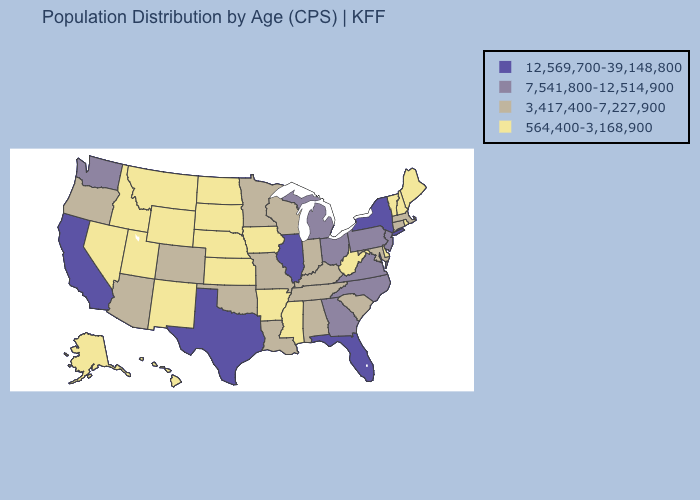What is the value of Colorado?
Concise answer only. 3,417,400-7,227,900. Among the states that border Massachusetts , does Rhode Island have the lowest value?
Answer briefly. Yes. Name the states that have a value in the range 3,417,400-7,227,900?
Short answer required. Alabama, Arizona, Colorado, Connecticut, Indiana, Kentucky, Louisiana, Maryland, Massachusetts, Minnesota, Missouri, Oklahoma, Oregon, South Carolina, Tennessee, Wisconsin. Does Arkansas have the same value as Utah?
Answer briefly. Yes. What is the highest value in states that border Massachusetts?
Give a very brief answer. 12,569,700-39,148,800. Among the states that border Rhode Island , which have the lowest value?
Give a very brief answer. Connecticut, Massachusetts. Name the states that have a value in the range 564,400-3,168,900?
Answer briefly. Alaska, Arkansas, Delaware, Hawaii, Idaho, Iowa, Kansas, Maine, Mississippi, Montana, Nebraska, Nevada, New Hampshire, New Mexico, North Dakota, Rhode Island, South Dakota, Utah, Vermont, West Virginia, Wyoming. Is the legend a continuous bar?
Keep it brief. No. What is the lowest value in states that border Kansas?
Be succinct. 564,400-3,168,900. Name the states that have a value in the range 564,400-3,168,900?
Be succinct. Alaska, Arkansas, Delaware, Hawaii, Idaho, Iowa, Kansas, Maine, Mississippi, Montana, Nebraska, Nevada, New Hampshire, New Mexico, North Dakota, Rhode Island, South Dakota, Utah, Vermont, West Virginia, Wyoming. Name the states that have a value in the range 3,417,400-7,227,900?
Write a very short answer. Alabama, Arizona, Colorado, Connecticut, Indiana, Kentucky, Louisiana, Maryland, Massachusetts, Minnesota, Missouri, Oklahoma, Oregon, South Carolina, Tennessee, Wisconsin. Does Florida have the highest value in the South?
Give a very brief answer. Yes. What is the value of Nebraska?
Quick response, please. 564,400-3,168,900. Name the states that have a value in the range 12,569,700-39,148,800?
Short answer required. California, Florida, Illinois, New York, Texas. Does Minnesota have a higher value than Delaware?
Give a very brief answer. Yes. 